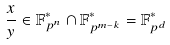<formula> <loc_0><loc_0><loc_500><loc_500>\frac { x } { y } \in \mathbb { F } _ { p ^ { n } } ^ { * } \cap \mathbb { F } _ { p ^ { m - k } } ^ { * } = \mathbb { F } _ { p ^ { d } } ^ { * }</formula> 